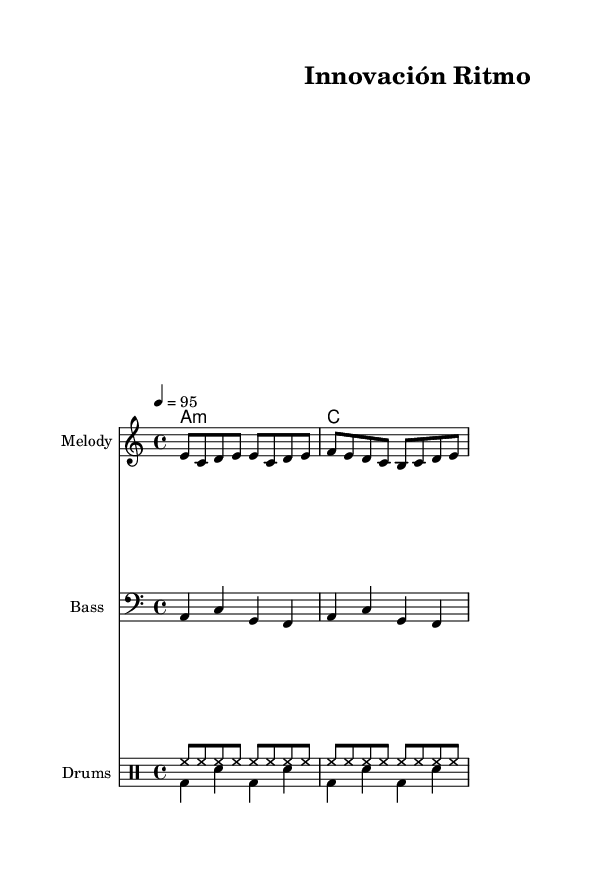What is the key signature of this music? The key signature is A minor, which has no sharps or flats. This can be found at the beginning of the music sheet, where the key signature is indicated.
Answer: A minor What is the time signature of this piece? The time signature is 4/4, which is noted at the beginning of the score, indicating that there are four beats in each measure and the quarter note gets one beat.
Answer: 4/4 What is the indicated tempo for the music? The tempo marking is 4 = 95, meaning the quarter note should be played at a speed of 95 beats per minute. This is found next to the tempo indication at the beginning of the music.
Answer: 95 How many measures are there in the melody? The melody consists of two measures, which can be determined by counting the vertical bar lines that separate the musical phrases in the melody section.
Answer: 2 What form of collaboration is emphasized in the lyrics? The lyrics emphasize "cooperación," which highlights the theme of collaboration in innovation. This can be found in the lyrics section, where words related to teamwork are presented.
Answer: colaboración How many distinct rhythmic patterns do the drums include? The drum section includes two distinct rhythmic patterns: one for the hi-hat and another for the bass and snare. This can be seen by analyzing the two drum voices, each with different notations.
Answer: 2 